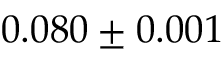Convert formula to latex. <formula><loc_0><loc_0><loc_500><loc_500>0 . 0 8 0 \pm 0 . 0 0 1</formula> 